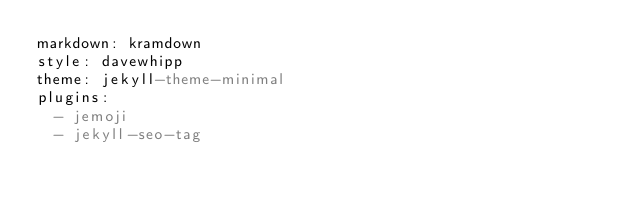Convert code to text. <code><loc_0><loc_0><loc_500><loc_500><_YAML_>markdown: kramdown
style: davewhipp
theme: jekyll-theme-minimal
plugins:
  - jemoji
  - jekyll-seo-tag
</code> 